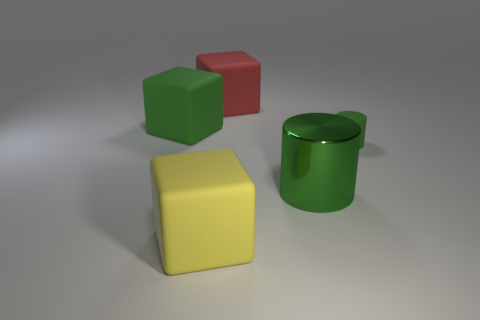Is there anything else that has the same material as the large cylinder?
Your answer should be very brief. No. Is the number of red rubber cubes that are in front of the red object less than the number of red matte cylinders?
Your response must be concise. No. What number of small rubber cylinders are the same color as the big metallic thing?
Keep it short and to the point. 1. How big is the green thing to the left of the yellow thing?
Provide a succinct answer. Large. The big green thing that is to the left of the large block in front of the big green thing to the right of the large yellow rubber object is what shape?
Offer a very short reply. Cube. There is a big rubber object that is on the right side of the large green block and in front of the large red matte thing; what is its shape?
Your answer should be very brief. Cube. Is there a green matte cube that has the same size as the green shiny cylinder?
Provide a succinct answer. Yes. There is a large rubber thing in front of the big metallic object; is its shape the same as the big red thing?
Your answer should be compact. Yes. Is the shape of the small green rubber thing the same as the yellow rubber thing?
Give a very brief answer. No. Are there any big green things that have the same shape as the small green thing?
Offer a very short reply. Yes. 